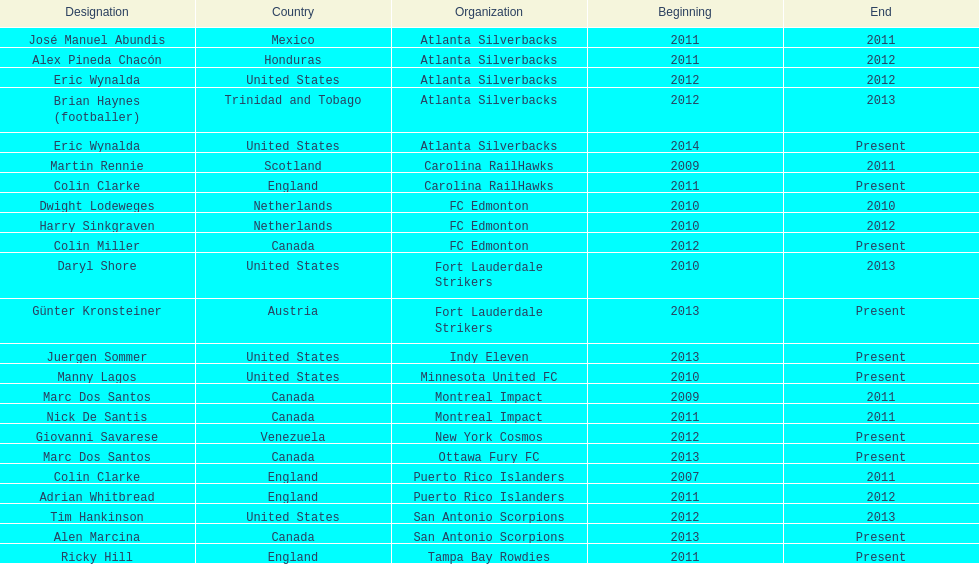How long did colin clarke coach the puerto rico islanders for? 4 years. 